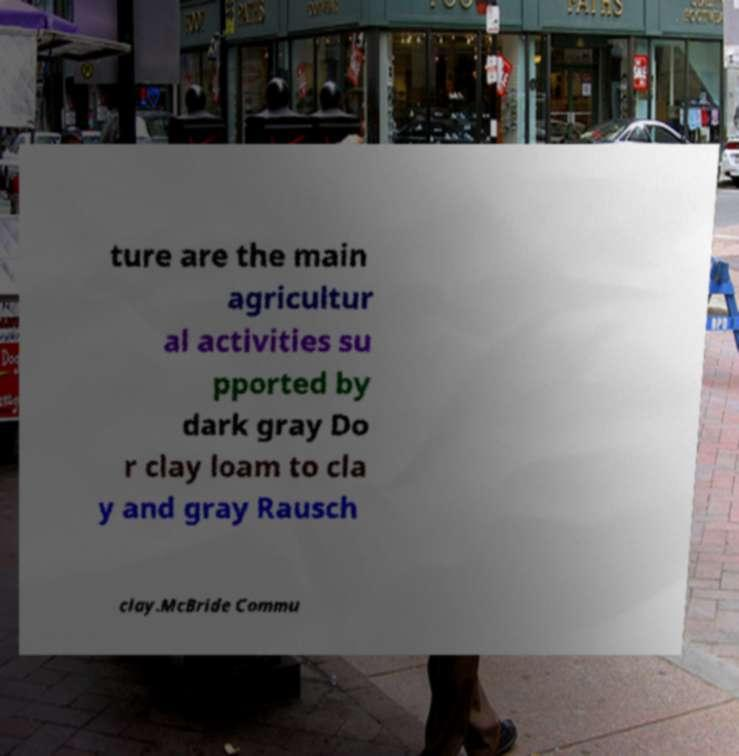There's text embedded in this image that I need extracted. Can you transcribe it verbatim? ture are the main agricultur al activities su pported by dark gray Do r clay loam to cla y and gray Rausch clay.McBride Commu 